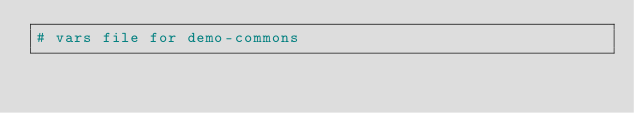Convert code to text. <code><loc_0><loc_0><loc_500><loc_500><_YAML_># vars file for demo-commons</code> 